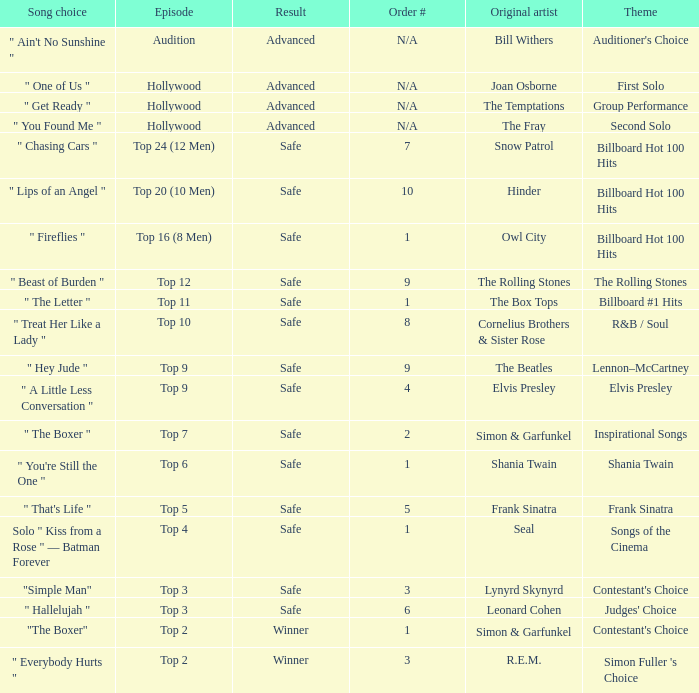The song choice " One of Us " has what themes? First Solo. 